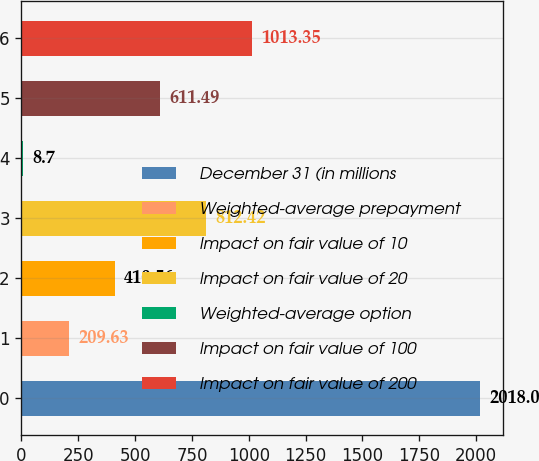Convert chart to OTSL. <chart><loc_0><loc_0><loc_500><loc_500><bar_chart><fcel>December 31 (in millions<fcel>Weighted-average prepayment<fcel>Impact on fair value of 10<fcel>Impact on fair value of 20<fcel>Weighted-average option<fcel>Impact on fair value of 100<fcel>Impact on fair value of 200<nl><fcel>2018<fcel>209.63<fcel>410.56<fcel>812.42<fcel>8.7<fcel>611.49<fcel>1013.35<nl></chart> 